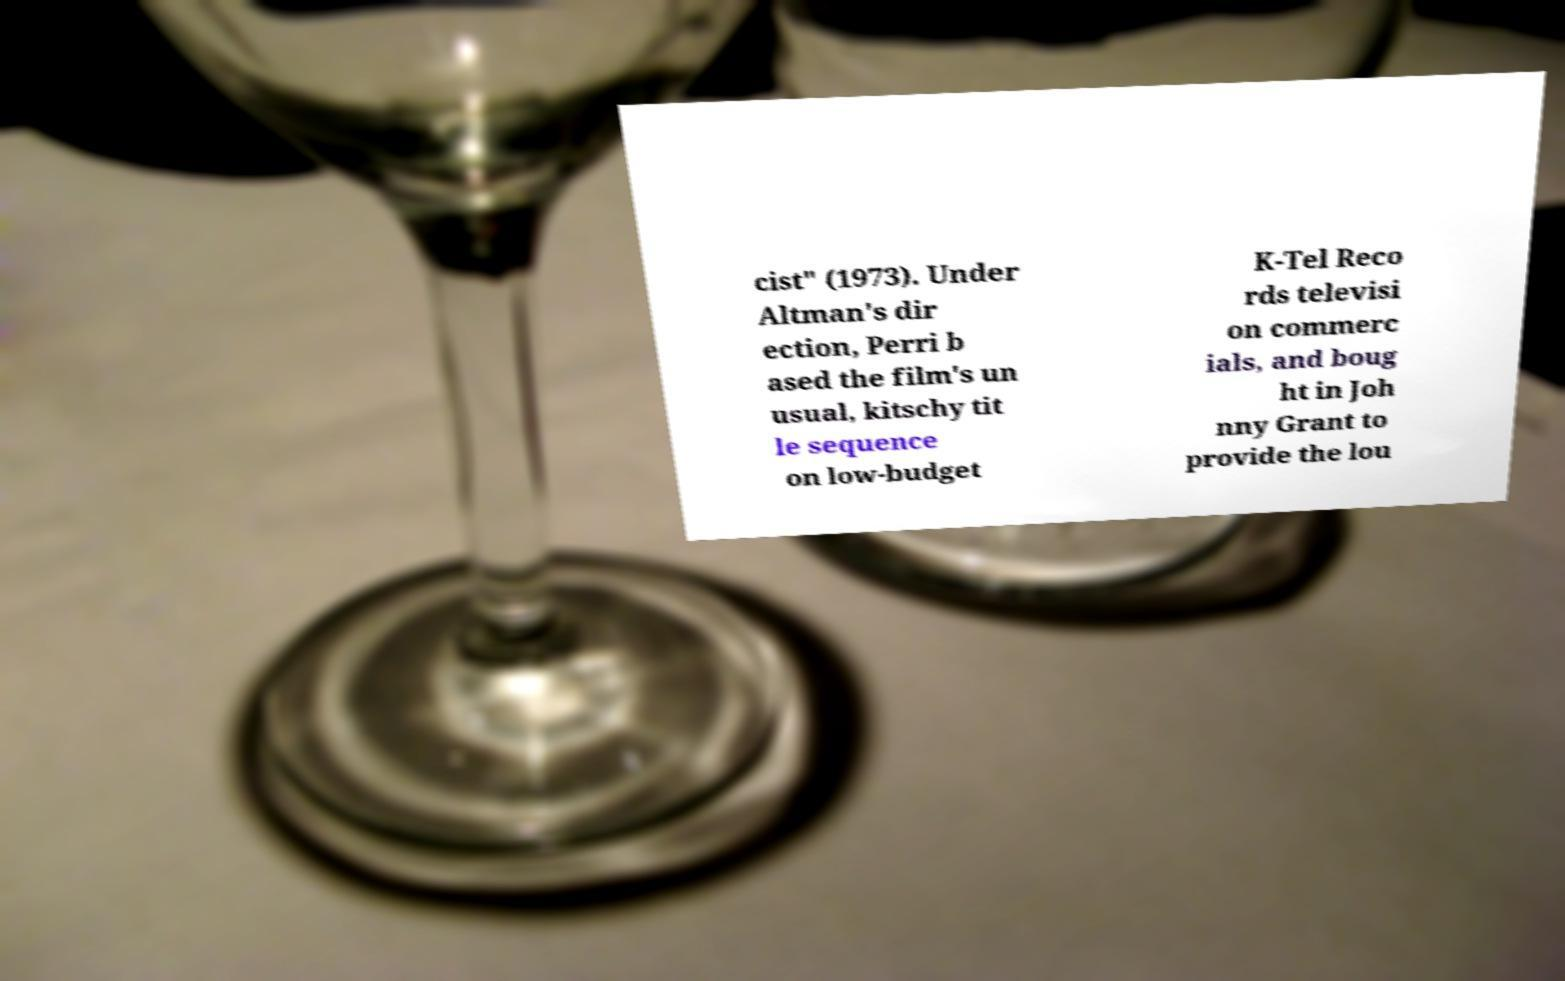Could you assist in decoding the text presented in this image and type it out clearly? cist" (1973). Under Altman's dir ection, Perri b ased the film's un usual, kitschy tit le sequence on low-budget K-Tel Reco rds televisi on commerc ials, and boug ht in Joh nny Grant to provide the lou 